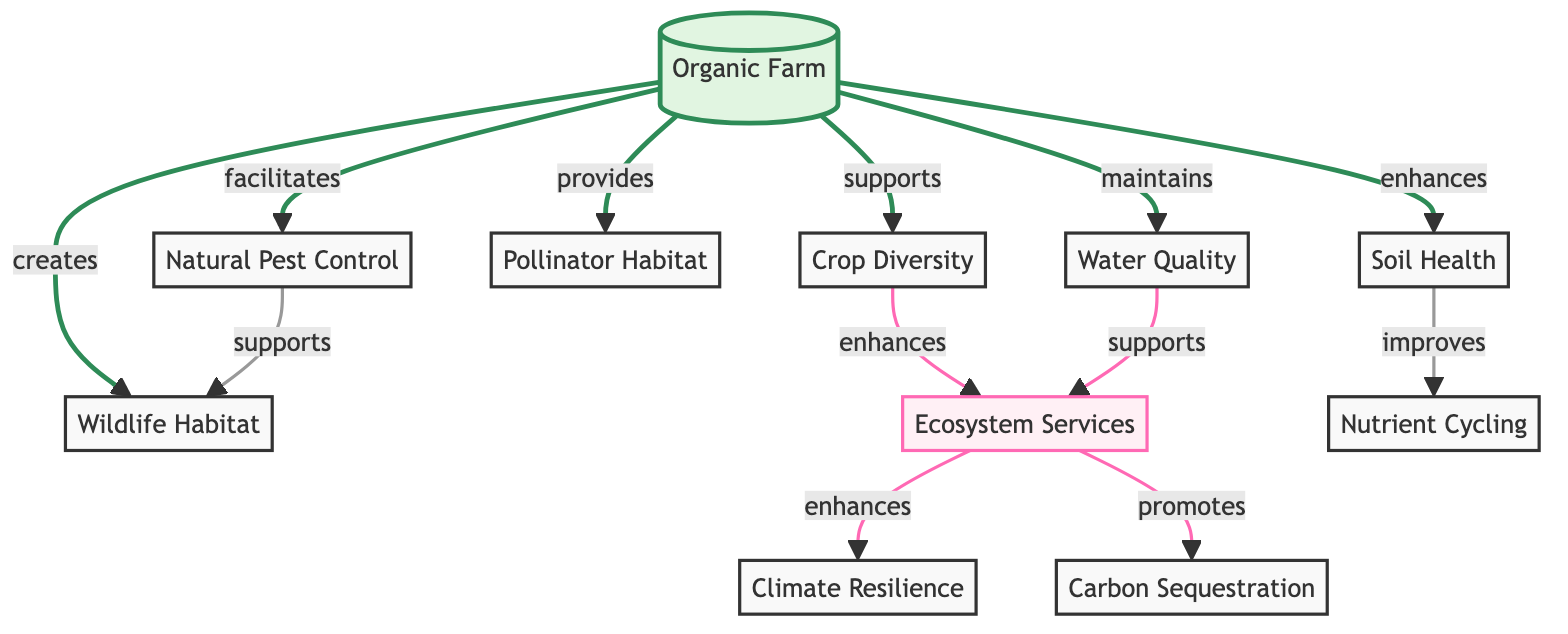What is the main subject of the diagram? The main subject of the diagram is clearly labeled as "Organic Farm," which is positioned at the top of the flowchart and acts as the central node connecting various aspects related to organic farming.
Answer: Organic Farm How many primary benefits are directly supported by the organic farm? By counting the arrows pointing from the "Organic Farm" node, there are six primary benefits connected directly: crop diversity, soil health, pollinator habitat, natural pest control, water quality, and wildlife habitat.
Answer: 6 Which aspect is indicated to enhance ecosystem services? "Crop Diversity" is directly connected with an arrow labeled "enhances" leading to "Ecosystem Services," showing that increasing crop diversity benefits the ecosystem services.
Answer: Crop Diversity What does soil health improve according to the diagram? The diagram indicates that "Soil Health" improves "Nutrient Cycling," connecting these two nodes with an arrow labeled "improves," illustrating the relationship between the two.
Answer: Nutrient Cycling What relationships support the promotion of carbon sequestration? "Ecosystem Services" promotes "Carbon Sequestration," and for this to occur, several other connections lead to ecosystem services, including enhanced climate resilience, which supports the argument that multiple aspects interconnected contribute to this promotion.
Answer: Ecosystem Services Which two aspects are linked by the relationship of "supports"? The diagram features several instances of "supports," but specifically, "Natural Pest Control" supports "Wildlife Habitat," highlighting a beneficial relationship between biological control methods and wildlife preservation.
Answer: Natural Pest Control and Wildlife Habitat What role does water quality play in the ecosystem? "Water Quality" directly connects to "Ecosystem Services" with a "supports" relationship, indicating that maintaining high water quality contributes positively to the range of ecosystem services provided.
Answer: Supports Ecosystem Services Which factor facilitates natural pest control? The diagram utilizes the term "facilitates" to link the "Organic Farm" to "Natural Pest Control," indicating that an organic farming environment helps to promote effective biological pest management strategies.
Answer: Organic Farm 